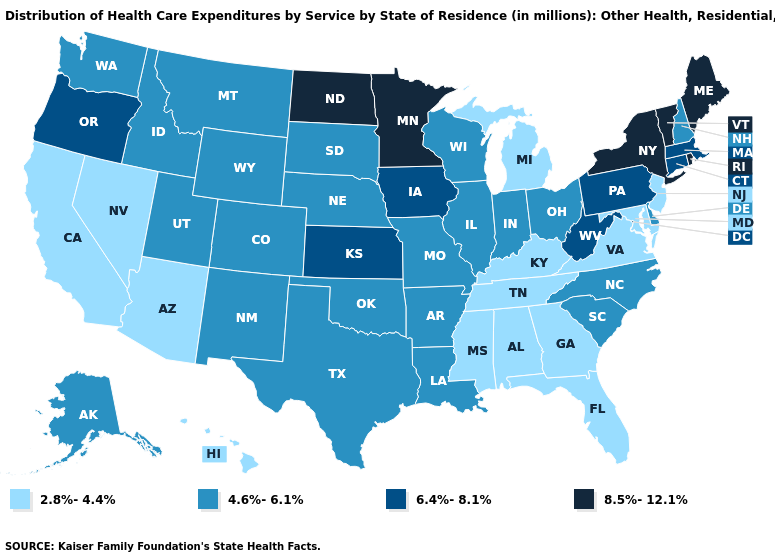Name the states that have a value in the range 2.8%-4.4%?
Keep it brief. Alabama, Arizona, California, Florida, Georgia, Hawaii, Kentucky, Maryland, Michigan, Mississippi, Nevada, New Jersey, Tennessee, Virginia. Among the states that border Iowa , which have the highest value?
Answer briefly. Minnesota. Does Oklahoma have the highest value in the USA?
Answer briefly. No. What is the value of Connecticut?
Be succinct. 6.4%-8.1%. Does New Hampshire have a lower value than South Carolina?
Short answer required. No. Does Tennessee have the same value as Florida?
Answer briefly. Yes. Name the states that have a value in the range 2.8%-4.4%?
Write a very short answer. Alabama, Arizona, California, Florida, Georgia, Hawaii, Kentucky, Maryland, Michigan, Mississippi, Nevada, New Jersey, Tennessee, Virginia. What is the value of Missouri?
Give a very brief answer. 4.6%-6.1%. Among the states that border Kansas , which have the highest value?
Give a very brief answer. Colorado, Missouri, Nebraska, Oklahoma. What is the highest value in the USA?
Keep it brief. 8.5%-12.1%. What is the lowest value in states that border New Jersey?
Keep it brief. 4.6%-6.1%. Is the legend a continuous bar?
Keep it brief. No. What is the lowest value in states that border Arizona?
Answer briefly. 2.8%-4.4%. Among the states that border Indiana , which have the lowest value?
Quick response, please. Kentucky, Michigan. Among the states that border North Carolina , which have the lowest value?
Be succinct. Georgia, Tennessee, Virginia. 